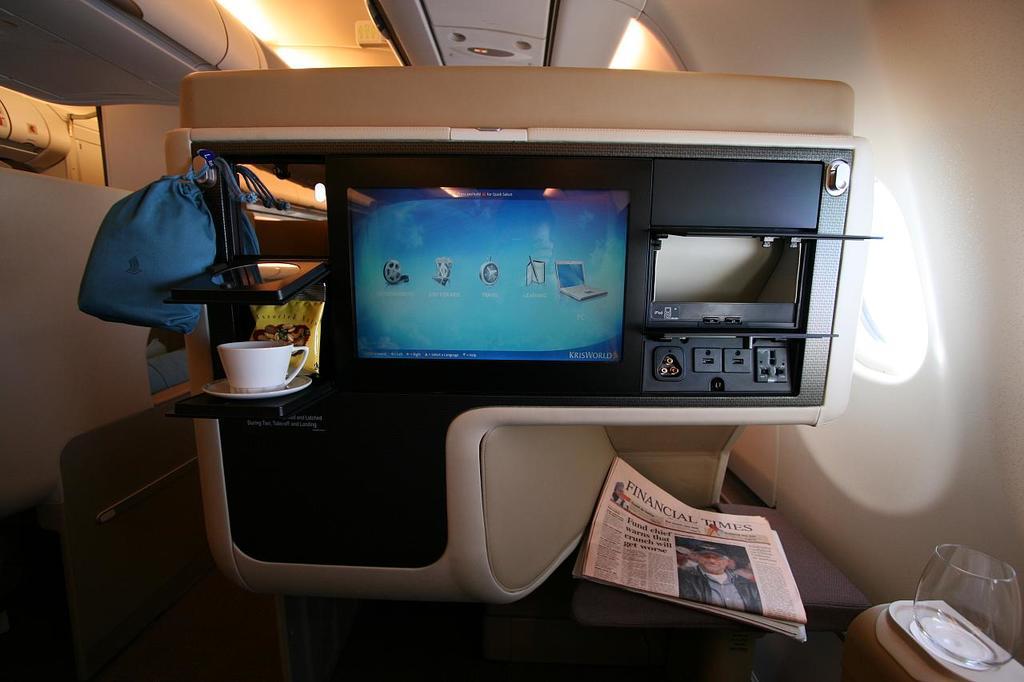What is the newspaper name?
Provide a short and direct response. Financial times. What is the headline of this page?
Offer a terse response. Financial times. 